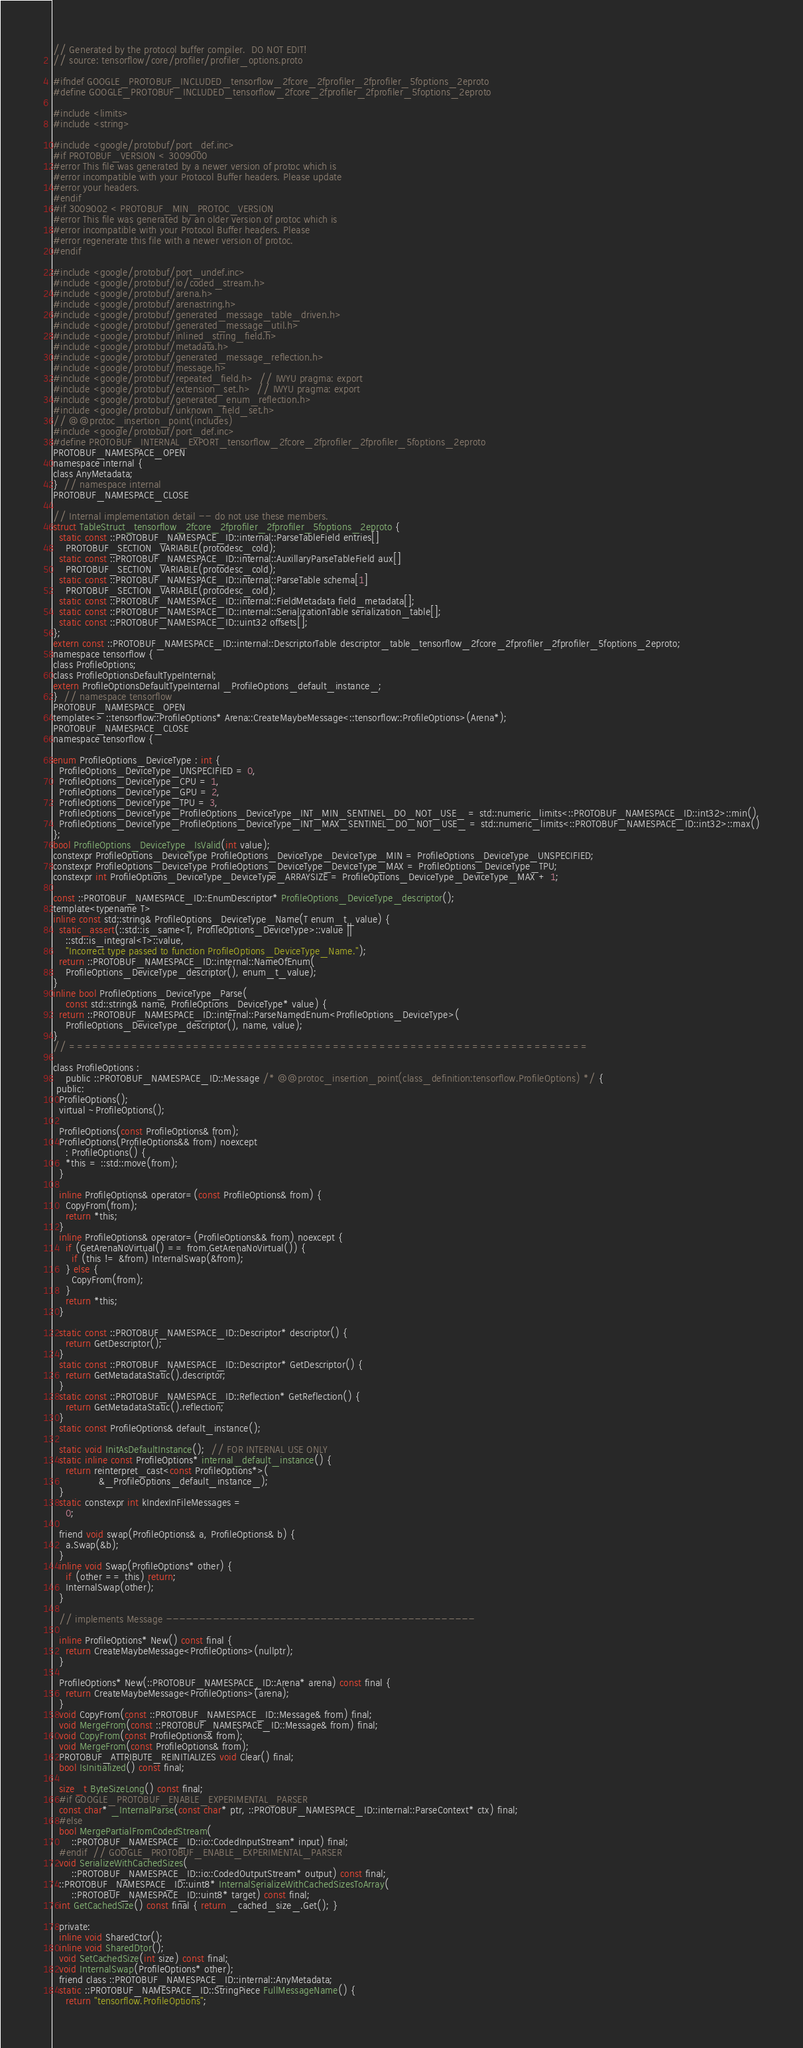<code> <loc_0><loc_0><loc_500><loc_500><_C_>// Generated by the protocol buffer compiler.  DO NOT EDIT!
// source: tensorflow/core/profiler/profiler_options.proto

#ifndef GOOGLE_PROTOBUF_INCLUDED_tensorflow_2fcore_2fprofiler_2fprofiler_5foptions_2eproto
#define GOOGLE_PROTOBUF_INCLUDED_tensorflow_2fcore_2fprofiler_2fprofiler_5foptions_2eproto

#include <limits>
#include <string>

#include <google/protobuf/port_def.inc>
#if PROTOBUF_VERSION < 3009000
#error This file was generated by a newer version of protoc which is
#error incompatible with your Protocol Buffer headers. Please update
#error your headers.
#endif
#if 3009002 < PROTOBUF_MIN_PROTOC_VERSION
#error This file was generated by an older version of protoc which is
#error incompatible with your Protocol Buffer headers. Please
#error regenerate this file with a newer version of protoc.
#endif

#include <google/protobuf/port_undef.inc>
#include <google/protobuf/io/coded_stream.h>
#include <google/protobuf/arena.h>
#include <google/protobuf/arenastring.h>
#include <google/protobuf/generated_message_table_driven.h>
#include <google/protobuf/generated_message_util.h>
#include <google/protobuf/inlined_string_field.h>
#include <google/protobuf/metadata.h>
#include <google/protobuf/generated_message_reflection.h>
#include <google/protobuf/message.h>
#include <google/protobuf/repeated_field.h>  // IWYU pragma: export
#include <google/protobuf/extension_set.h>  // IWYU pragma: export
#include <google/protobuf/generated_enum_reflection.h>
#include <google/protobuf/unknown_field_set.h>
// @@protoc_insertion_point(includes)
#include <google/protobuf/port_def.inc>
#define PROTOBUF_INTERNAL_EXPORT_tensorflow_2fcore_2fprofiler_2fprofiler_5foptions_2eproto
PROTOBUF_NAMESPACE_OPEN
namespace internal {
class AnyMetadata;
}  // namespace internal
PROTOBUF_NAMESPACE_CLOSE

// Internal implementation detail -- do not use these members.
struct TableStruct_tensorflow_2fcore_2fprofiler_2fprofiler_5foptions_2eproto {
  static const ::PROTOBUF_NAMESPACE_ID::internal::ParseTableField entries[]
    PROTOBUF_SECTION_VARIABLE(protodesc_cold);
  static const ::PROTOBUF_NAMESPACE_ID::internal::AuxillaryParseTableField aux[]
    PROTOBUF_SECTION_VARIABLE(protodesc_cold);
  static const ::PROTOBUF_NAMESPACE_ID::internal::ParseTable schema[1]
    PROTOBUF_SECTION_VARIABLE(protodesc_cold);
  static const ::PROTOBUF_NAMESPACE_ID::internal::FieldMetadata field_metadata[];
  static const ::PROTOBUF_NAMESPACE_ID::internal::SerializationTable serialization_table[];
  static const ::PROTOBUF_NAMESPACE_ID::uint32 offsets[];
};
extern const ::PROTOBUF_NAMESPACE_ID::internal::DescriptorTable descriptor_table_tensorflow_2fcore_2fprofiler_2fprofiler_5foptions_2eproto;
namespace tensorflow {
class ProfileOptions;
class ProfileOptionsDefaultTypeInternal;
extern ProfileOptionsDefaultTypeInternal _ProfileOptions_default_instance_;
}  // namespace tensorflow
PROTOBUF_NAMESPACE_OPEN
template<> ::tensorflow::ProfileOptions* Arena::CreateMaybeMessage<::tensorflow::ProfileOptions>(Arena*);
PROTOBUF_NAMESPACE_CLOSE
namespace tensorflow {

enum ProfileOptions_DeviceType : int {
  ProfileOptions_DeviceType_UNSPECIFIED = 0,
  ProfileOptions_DeviceType_CPU = 1,
  ProfileOptions_DeviceType_GPU = 2,
  ProfileOptions_DeviceType_TPU = 3,
  ProfileOptions_DeviceType_ProfileOptions_DeviceType_INT_MIN_SENTINEL_DO_NOT_USE_ = std::numeric_limits<::PROTOBUF_NAMESPACE_ID::int32>::min(),
  ProfileOptions_DeviceType_ProfileOptions_DeviceType_INT_MAX_SENTINEL_DO_NOT_USE_ = std::numeric_limits<::PROTOBUF_NAMESPACE_ID::int32>::max()
};
bool ProfileOptions_DeviceType_IsValid(int value);
constexpr ProfileOptions_DeviceType ProfileOptions_DeviceType_DeviceType_MIN = ProfileOptions_DeviceType_UNSPECIFIED;
constexpr ProfileOptions_DeviceType ProfileOptions_DeviceType_DeviceType_MAX = ProfileOptions_DeviceType_TPU;
constexpr int ProfileOptions_DeviceType_DeviceType_ARRAYSIZE = ProfileOptions_DeviceType_DeviceType_MAX + 1;

const ::PROTOBUF_NAMESPACE_ID::EnumDescriptor* ProfileOptions_DeviceType_descriptor();
template<typename T>
inline const std::string& ProfileOptions_DeviceType_Name(T enum_t_value) {
  static_assert(::std::is_same<T, ProfileOptions_DeviceType>::value ||
    ::std::is_integral<T>::value,
    "Incorrect type passed to function ProfileOptions_DeviceType_Name.");
  return ::PROTOBUF_NAMESPACE_ID::internal::NameOfEnum(
    ProfileOptions_DeviceType_descriptor(), enum_t_value);
}
inline bool ProfileOptions_DeviceType_Parse(
    const std::string& name, ProfileOptions_DeviceType* value) {
  return ::PROTOBUF_NAMESPACE_ID::internal::ParseNamedEnum<ProfileOptions_DeviceType>(
    ProfileOptions_DeviceType_descriptor(), name, value);
}
// ===================================================================

class ProfileOptions :
    public ::PROTOBUF_NAMESPACE_ID::Message /* @@protoc_insertion_point(class_definition:tensorflow.ProfileOptions) */ {
 public:
  ProfileOptions();
  virtual ~ProfileOptions();

  ProfileOptions(const ProfileOptions& from);
  ProfileOptions(ProfileOptions&& from) noexcept
    : ProfileOptions() {
    *this = ::std::move(from);
  }

  inline ProfileOptions& operator=(const ProfileOptions& from) {
    CopyFrom(from);
    return *this;
  }
  inline ProfileOptions& operator=(ProfileOptions&& from) noexcept {
    if (GetArenaNoVirtual() == from.GetArenaNoVirtual()) {
      if (this != &from) InternalSwap(&from);
    } else {
      CopyFrom(from);
    }
    return *this;
  }

  static const ::PROTOBUF_NAMESPACE_ID::Descriptor* descriptor() {
    return GetDescriptor();
  }
  static const ::PROTOBUF_NAMESPACE_ID::Descriptor* GetDescriptor() {
    return GetMetadataStatic().descriptor;
  }
  static const ::PROTOBUF_NAMESPACE_ID::Reflection* GetReflection() {
    return GetMetadataStatic().reflection;
  }
  static const ProfileOptions& default_instance();

  static void InitAsDefaultInstance();  // FOR INTERNAL USE ONLY
  static inline const ProfileOptions* internal_default_instance() {
    return reinterpret_cast<const ProfileOptions*>(
               &_ProfileOptions_default_instance_);
  }
  static constexpr int kIndexInFileMessages =
    0;

  friend void swap(ProfileOptions& a, ProfileOptions& b) {
    a.Swap(&b);
  }
  inline void Swap(ProfileOptions* other) {
    if (other == this) return;
    InternalSwap(other);
  }

  // implements Message ----------------------------------------------

  inline ProfileOptions* New() const final {
    return CreateMaybeMessage<ProfileOptions>(nullptr);
  }

  ProfileOptions* New(::PROTOBUF_NAMESPACE_ID::Arena* arena) const final {
    return CreateMaybeMessage<ProfileOptions>(arena);
  }
  void CopyFrom(const ::PROTOBUF_NAMESPACE_ID::Message& from) final;
  void MergeFrom(const ::PROTOBUF_NAMESPACE_ID::Message& from) final;
  void CopyFrom(const ProfileOptions& from);
  void MergeFrom(const ProfileOptions& from);
  PROTOBUF_ATTRIBUTE_REINITIALIZES void Clear() final;
  bool IsInitialized() const final;

  size_t ByteSizeLong() const final;
  #if GOOGLE_PROTOBUF_ENABLE_EXPERIMENTAL_PARSER
  const char* _InternalParse(const char* ptr, ::PROTOBUF_NAMESPACE_ID::internal::ParseContext* ctx) final;
  #else
  bool MergePartialFromCodedStream(
      ::PROTOBUF_NAMESPACE_ID::io::CodedInputStream* input) final;
  #endif  // GOOGLE_PROTOBUF_ENABLE_EXPERIMENTAL_PARSER
  void SerializeWithCachedSizes(
      ::PROTOBUF_NAMESPACE_ID::io::CodedOutputStream* output) const final;
  ::PROTOBUF_NAMESPACE_ID::uint8* InternalSerializeWithCachedSizesToArray(
      ::PROTOBUF_NAMESPACE_ID::uint8* target) const final;
  int GetCachedSize() const final { return _cached_size_.Get(); }

  private:
  inline void SharedCtor();
  inline void SharedDtor();
  void SetCachedSize(int size) const final;
  void InternalSwap(ProfileOptions* other);
  friend class ::PROTOBUF_NAMESPACE_ID::internal::AnyMetadata;
  static ::PROTOBUF_NAMESPACE_ID::StringPiece FullMessageName() {
    return "tensorflow.ProfileOptions";</code> 